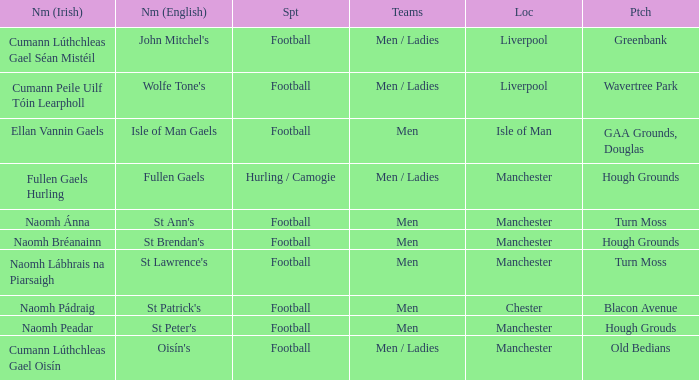Would you mind parsing the complete table? {'header': ['Nm (Irish)', 'Nm (English)', 'Spt', 'Teams', 'Loc', 'Ptch'], 'rows': [['Cumann Lúthchleas Gael Séan Mistéil', "John Mitchel's", 'Football', 'Men / Ladies', 'Liverpool', 'Greenbank'], ['Cumann Peile Uilf Tóin Learpholl', "Wolfe Tone's", 'Football', 'Men / Ladies', 'Liverpool', 'Wavertree Park'], ['Ellan Vannin Gaels', 'Isle of Man Gaels', 'Football', 'Men', 'Isle of Man', 'GAA Grounds, Douglas'], ['Fullen Gaels Hurling', 'Fullen Gaels', 'Hurling / Camogie', 'Men / Ladies', 'Manchester', 'Hough Grounds'], ['Naomh Ánna', "St Ann's", 'Football', 'Men', 'Manchester', 'Turn Moss'], ['Naomh Bréanainn', "St Brendan's", 'Football', 'Men', 'Manchester', 'Hough Grounds'], ['Naomh Lábhrais na Piarsaigh', "St Lawrence's", 'Football', 'Men', 'Manchester', 'Turn Moss'], ['Naomh Pádraig', "St Patrick's", 'Football', 'Men', 'Chester', 'Blacon Avenue'], ['Naomh Peadar', "St Peter's", 'Football', 'Men', 'Manchester', 'Hough Grouds'], ['Cumann Lúthchleas Gael Oisín', "Oisín's", 'Football', 'Men / Ladies', 'Manchester', 'Old Bedians']]} What is the English Name of the Location in Chester? St Patrick's. 